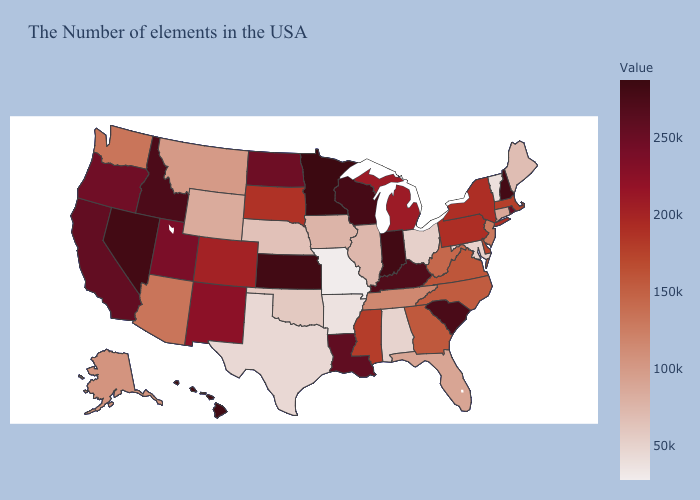Among the states that border California , does Nevada have the highest value?
Quick response, please. Yes. Among the states that border Delaware , does New Jersey have the lowest value?
Give a very brief answer. No. Among the states that border Massachusetts , does New York have the highest value?
Keep it brief. No. Is the legend a continuous bar?
Quick response, please. Yes. Which states have the lowest value in the West?
Write a very short answer. Wyoming. Does South Carolina have the highest value in the South?
Give a very brief answer. Yes. Which states hav the highest value in the West?
Keep it brief. Hawaii. 